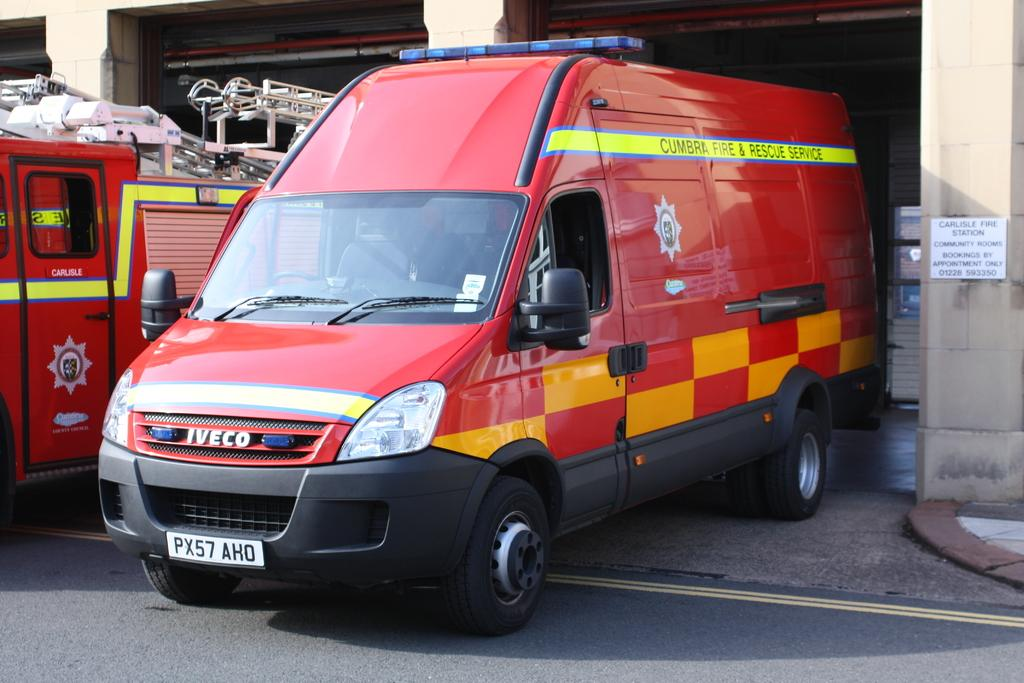<image>
Provide a brief description of the given image. an IVECO colorful red and yellow checked ban leaves a parking garage 